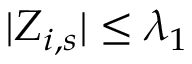<formula> <loc_0><loc_0><loc_500><loc_500>| Z _ { i , s } | \leq \lambda _ { 1 }</formula> 